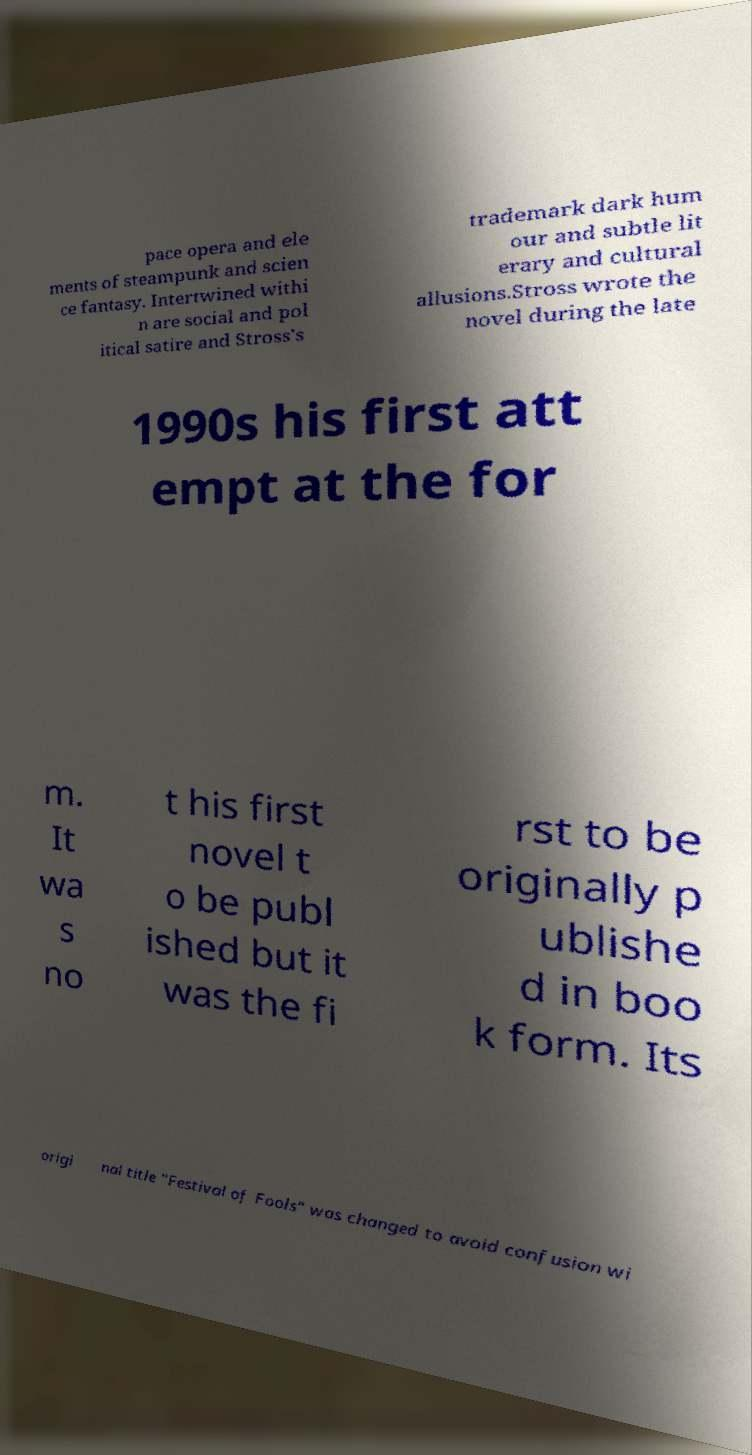Can you read and provide the text displayed in the image?This photo seems to have some interesting text. Can you extract and type it out for me? pace opera and ele ments of steampunk and scien ce fantasy. Intertwined withi n are social and pol itical satire and Stross's trademark dark hum our and subtle lit erary and cultural allusions.Stross wrote the novel during the late 1990s his first att empt at the for m. It wa s no t his first novel t o be publ ished but it was the fi rst to be originally p ublishe d in boo k form. Its origi nal title "Festival of Fools" was changed to avoid confusion wi 